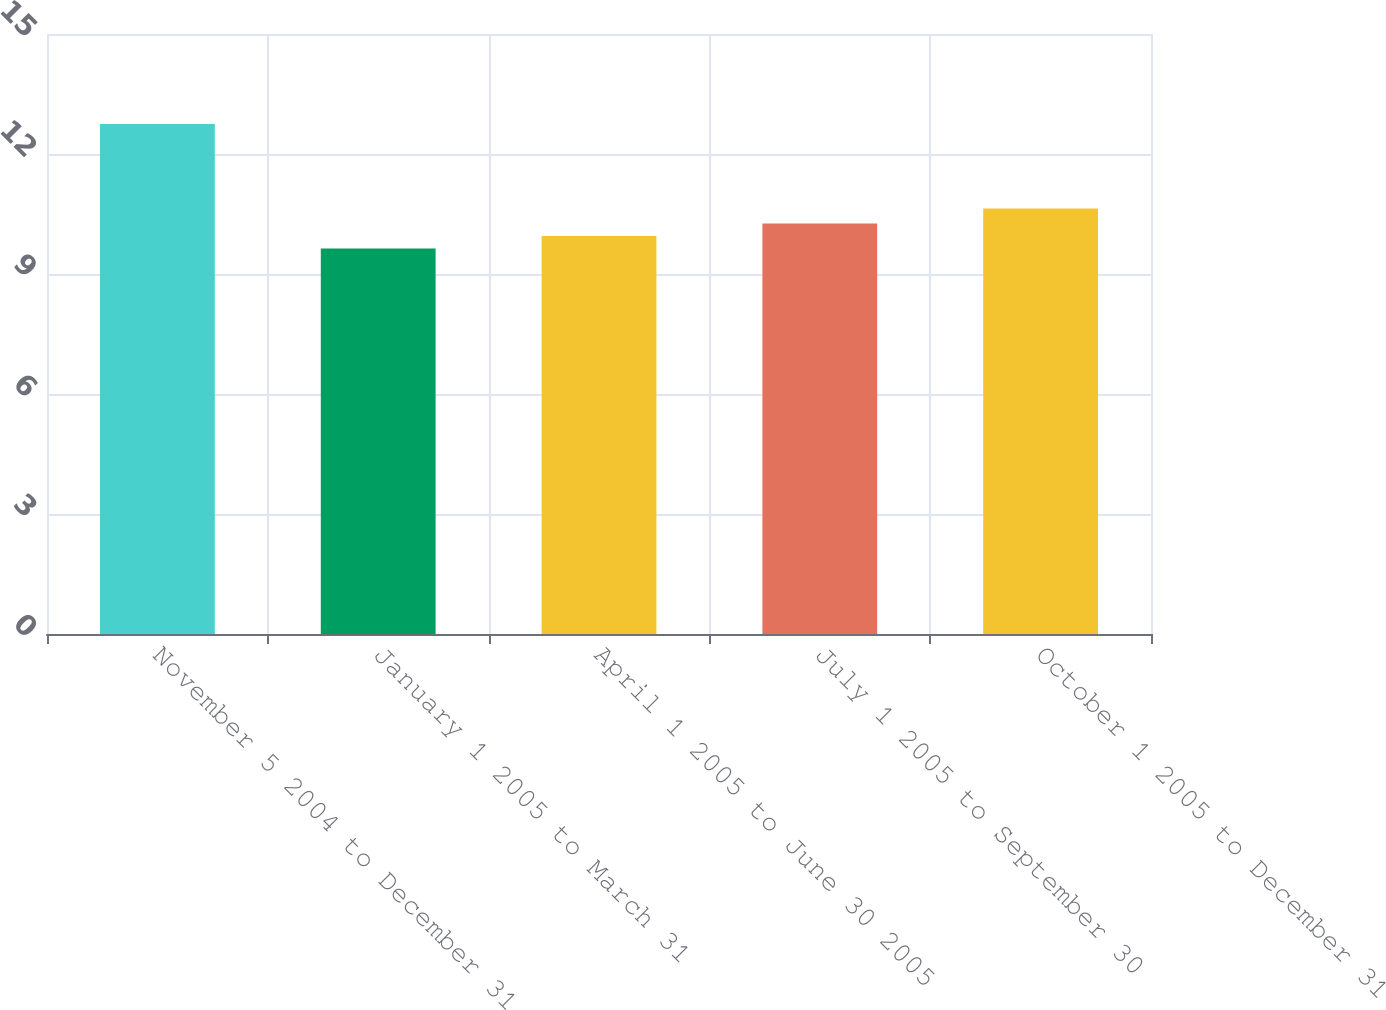Convert chart to OTSL. <chart><loc_0><loc_0><loc_500><loc_500><bar_chart><fcel>November 5 2004 to December 31<fcel>January 1 2005 to March 31<fcel>April 1 2005 to June 30 2005<fcel>July 1 2005 to September 30<fcel>October 1 2005 to December 31<nl><fcel>12.75<fcel>9.64<fcel>9.95<fcel>10.26<fcel>10.64<nl></chart> 